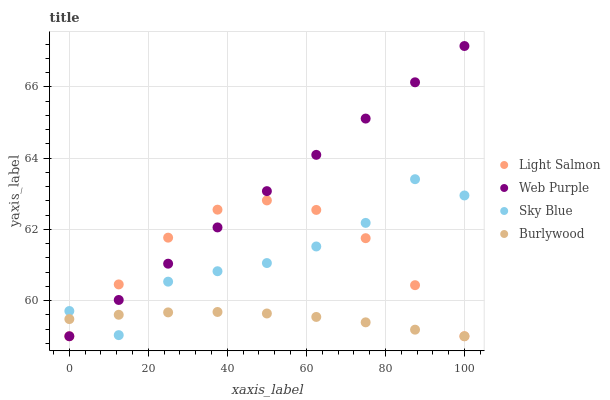Does Burlywood have the minimum area under the curve?
Answer yes or no. Yes. Does Web Purple have the maximum area under the curve?
Answer yes or no. Yes. Does Sky Blue have the minimum area under the curve?
Answer yes or no. No. Does Sky Blue have the maximum area under the curve?
Answer yes or no. No. Is Web Purple the smoothest?
Answer yes or no. Yes. Is Sky Blue the roughest?
Answer yes or no. Yes. Is Light Salmon the smoothest?
Answer yes or no. No. Is Light Salmon the roughest?
Answer yes or no. No. Does Burlywood have the lowest value?
Answer yes or no. Yes. Does Sky Blue have the lowest value?
Answer yes or no. No. Does Web Purple have the highest value?
Answer yes or no. Yes. Does Sky Blue have the highest value?
Answer yes or no. No. Does Sky Blue intersect Light Salmon?
Answer yes or no. Yes. Is Sky Blue less than Light Salmon?
Answer yes or no. No. Is Sky Blue greater than Light Salmon?
Answer yes or no. No. 